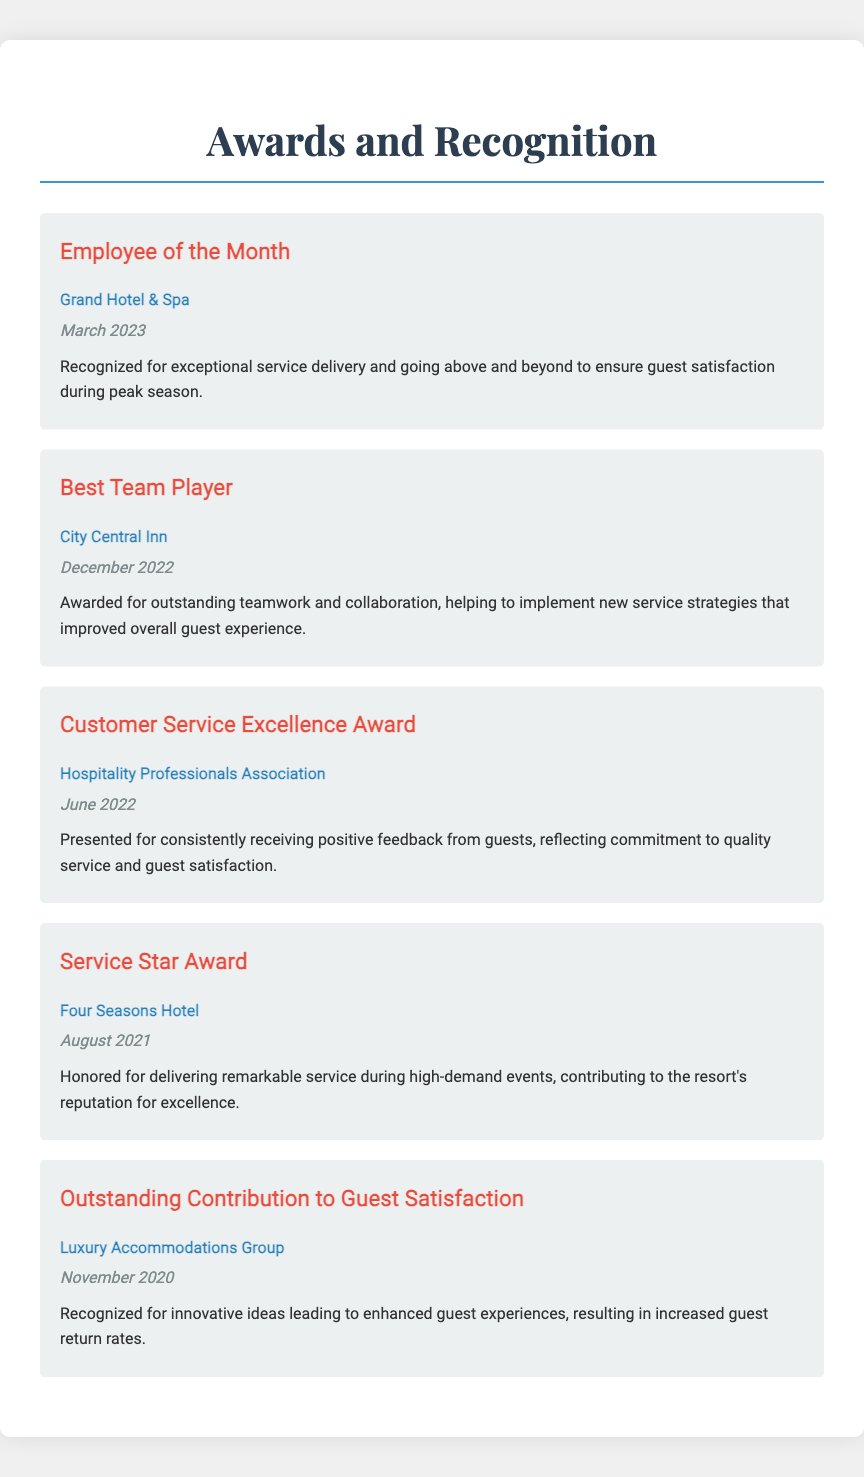what is the title of the first award listed? The first award listed in the document is the "Employee of the Month."
Answer: Employee of the Month which organization awarded the "Best Team Player" title? The "Best Team Player" award was given by City Central Inn.
Answer: City Central Inn when was the "Customer Service Excellence Award" received? The "Customer Service Excellence Award" was received in June 2022.
Answer: June 2022 how many awards are listed in total? There are five awards described in the document.
Answer: five which award recognizes innovative ideas leading to enhanced guest experiences? The award recognizing innovative ideas is the "Outstanding Contribution to Guest Satisfaction."
Answer: Outstanding Contribution to Guest Satisfaction who recognized the "Service Star Award"? The "Service Star Award" was honored by Four Seasons Hotel.
Answer: Four Seasons Hotel what was the reason for the "Employee of the Month" recognition? The recognition was for exceptional service delivery and going above and beyond to ensure guest satisfaction.
Answer: exceptional service delivery which award highlights contributions to guest satisfaction in a high-demand event setting? The award that highlights contributions during high-demand events is the "Service Star Award."
Answer: Service Star Award what is a common theme among these awards? A common theme is outstanding service and contributions to guest satisfaction.
Answer: outstanding service and contributions to guest satisfaction 